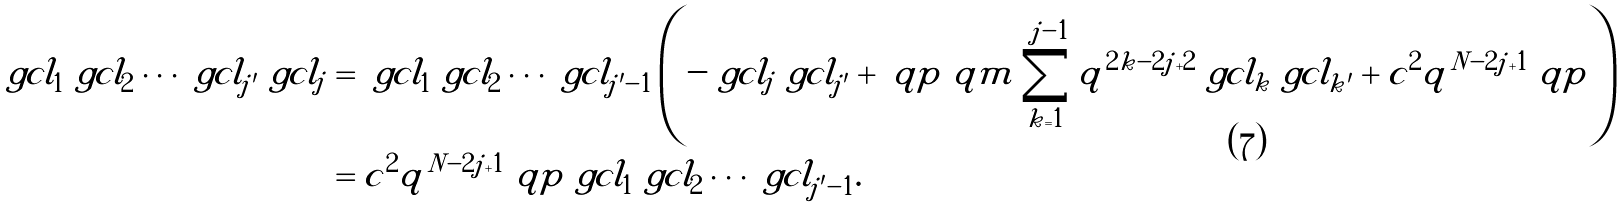<formula> <loc_0><loc_0><loc_500><loc_500>\ g c l _ { 1 } \ g c l _ { 2 } \cdots \ g c l _ { j ^ { \prime } } \ g c l _ { j } & = \ g c l _ { 1 } \ g c l _ { 2 } \cdots \ g c l _ { j ^ { \prime } - 1 } \left ( - \ g c l _ { j } \ g c l _ { j ^ { \prime } } + \ q p \ q m \sum _ { k = 1 } ^ { j - 1 } q ^ { 2 k - 2 j + 2 } \ g c l _ { k } \ g c l _ { k ^ { \prime } } + c ^ { 2 } q ^ { N - 2 j + 1 } \ q p \right ) \\ & = c ^ { 2 } q ^ { N - 2 j + 1 } \ q p \ g c l _ { 1 } \ g c l _ { 2 } \cdots \ g c l _ { j ^ { \prime } - 1 } .</formula> 